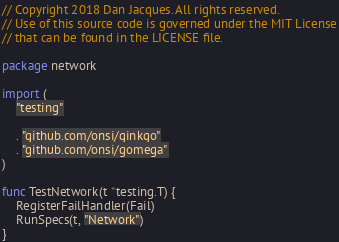Convert code to text. <code><loc_0><loc_0><loc_500><loc_500><_Go_>// Copyright 2018 Dan Jacques. All rights reserved.
// Use of this source code is governed under the MIT License
// that can be found in the LICENSE file.

package network

import (
	"testing"

	. "github.com/onsi/ginkgo"
	. "github.com/onsi/gomega"
)

func TestNetwork(t *testing.T) {
	RegisterFailHandler(Fail)
	RunSpecs(t, "Network")
}
</code> 